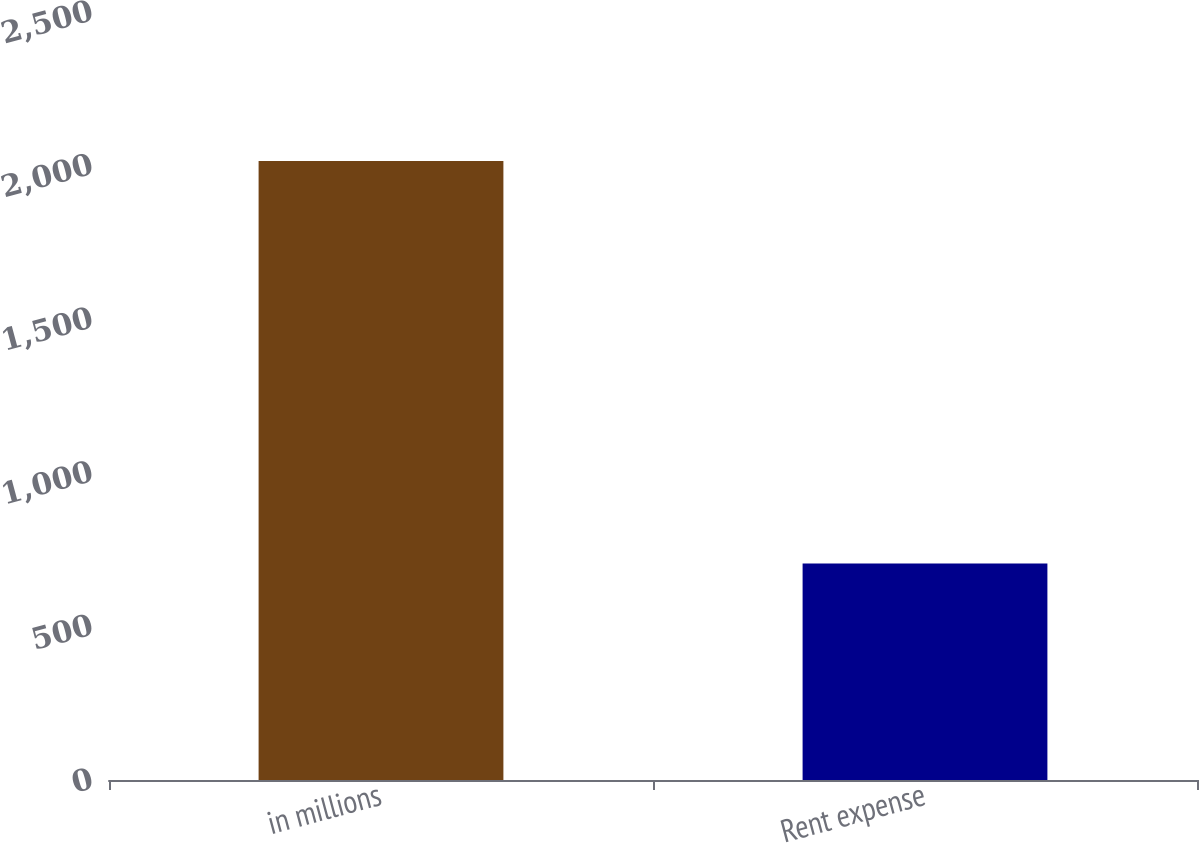<chart> <loc_0><loc_0><loc_500><loc_500><bar_chart><fcel>in millions<fcel>Rent expense<nl><fcel>2015<fcel>705<nl></chart> 